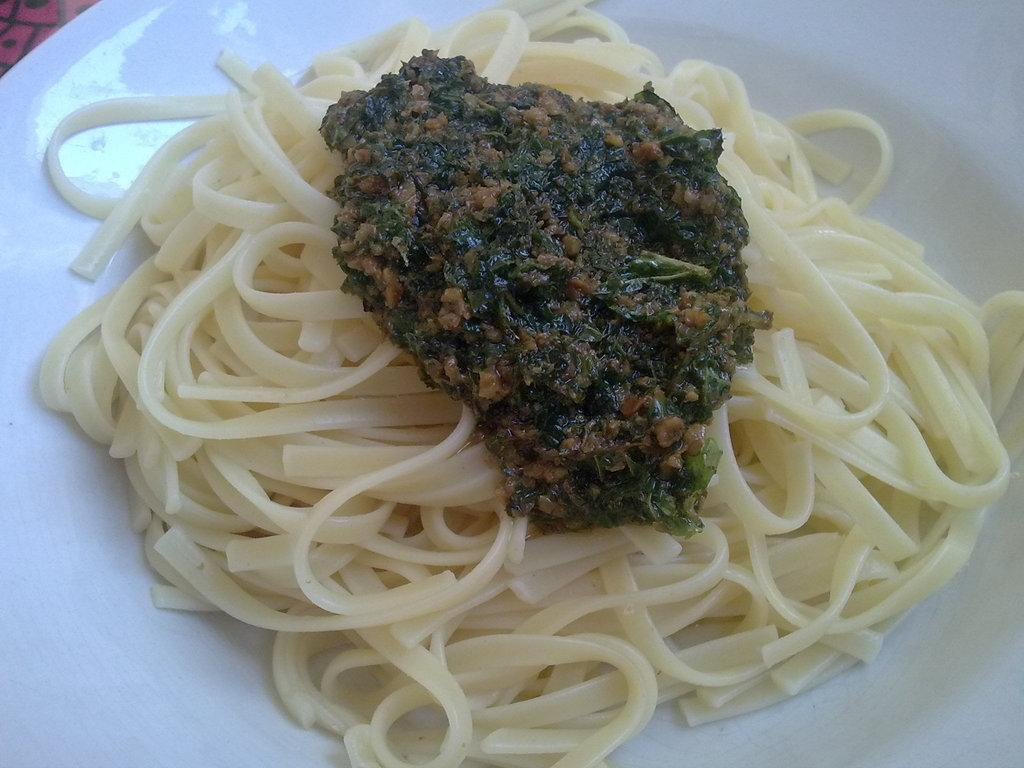What type of food can be seen in the image? There is spaghetti in the image. Are there any other food items visible besides the spaghetti? Yes, there are other food items in the image. What color is the plate that the food is on? There is a white plate in the image. Is there a veil covering the spaghetti in the image? No, there is no veil present in the image. Can the spaghetti change its color in the image? No, the color of the spaghetti cannot change in the image. 